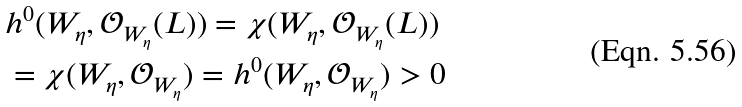Convert formula to latex. <formula><loc_0><loc_0><loc_500><loc_500>& h ^ { 0 } ( W _ { \eta } , \mathcal { O } _ { W _ { \eta } } ( L ) ) = \chi ( W _ { \eta } , \mathcal { O } _ { W _ { \eta } } ( L ) ) \\ & = \chi ( W _ { \eta } , \mathcal { O } _ { W _ { \eta } } ) = h ^ { 0 } ( W _ { \eta } , \mathcal { O } _ { W _ { \eta } } ) > 0</formula> 